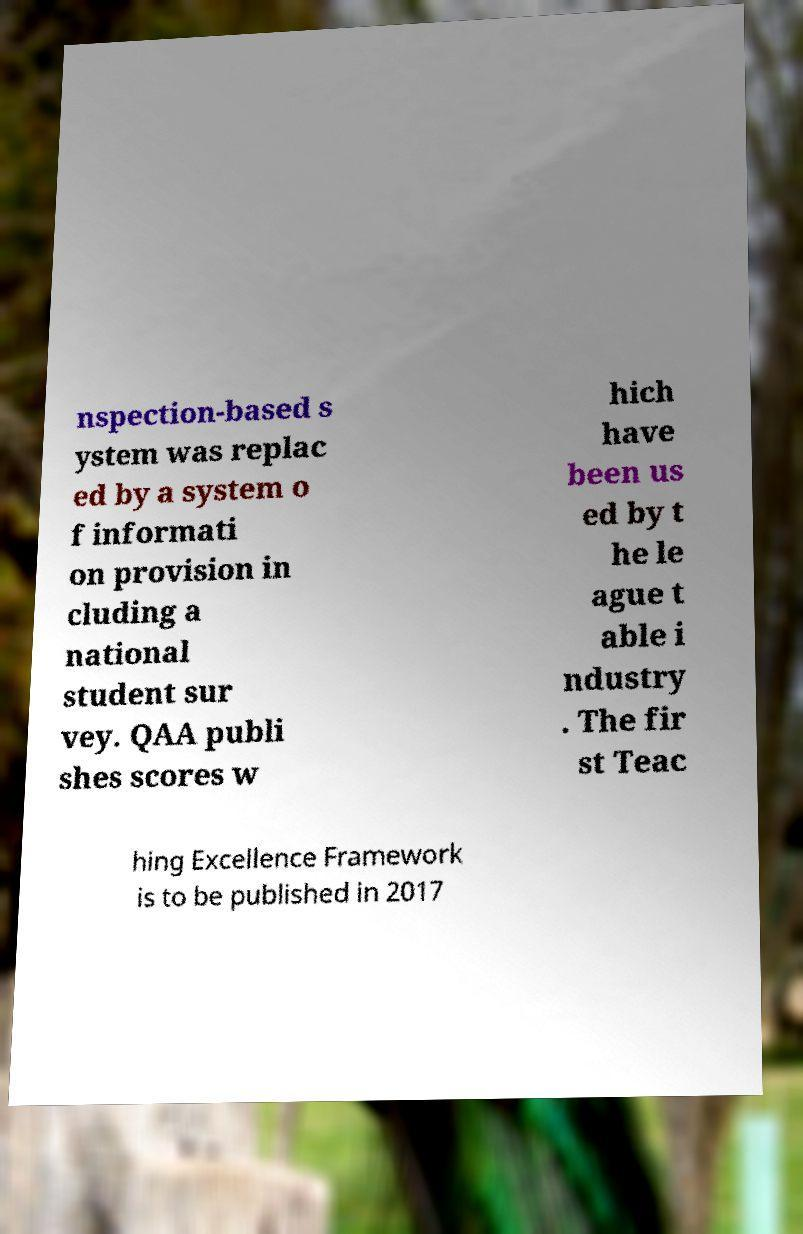I need the written content from this picture converted into text. Can you do that? nspection-based s ystem was replac ed by a system o f informati on provision in cluding a national student sur vey. QAA publi shes scores w hich have been us ed by t he le ague t able i ndustry . The fir st Teac hing Excellence Framework is to be published in 2017 